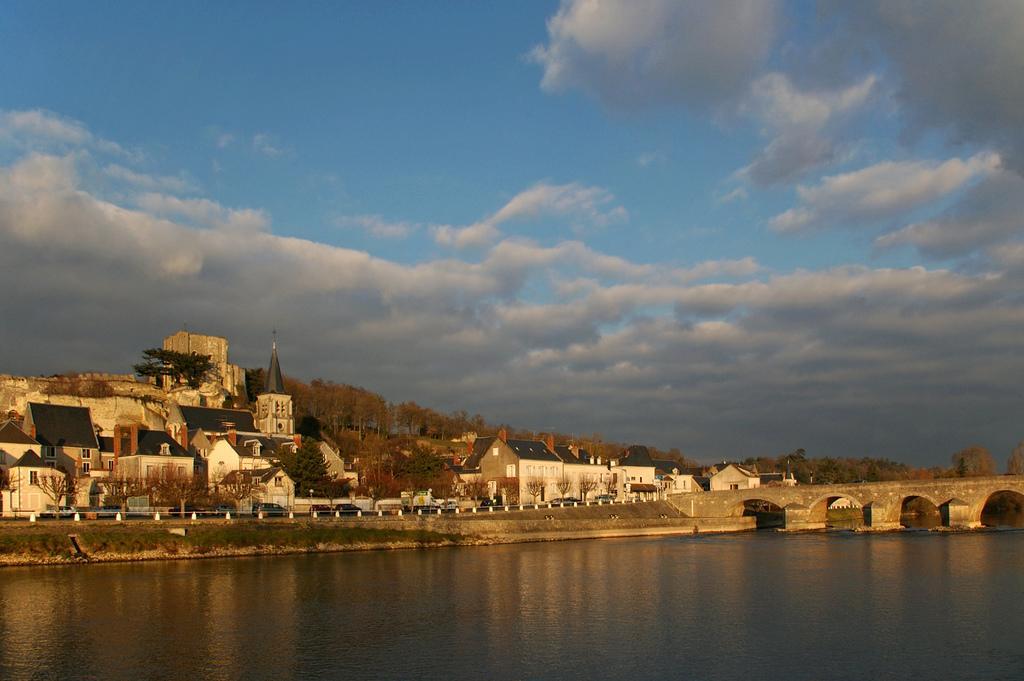In one or two sentences, can you explain what this image depicts? In this image I can see there are few buildings, trees and there is a lake, there is a bridge at right side and the sky is cloudy. 